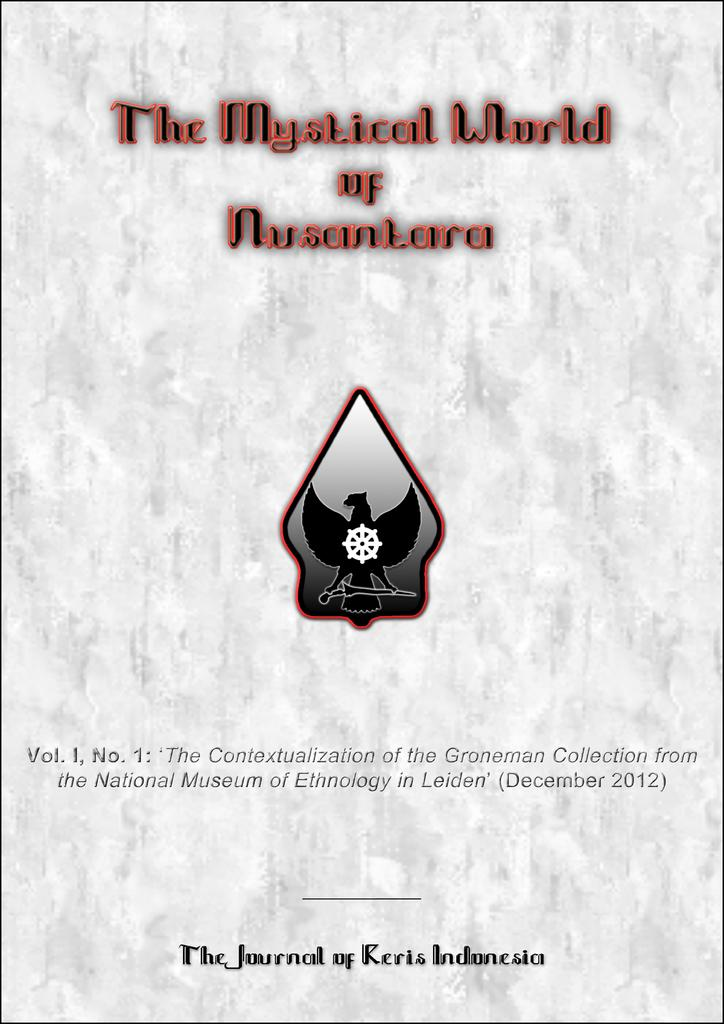<image>
Create a compact narrative representing the image presented. The introduction page of The Mystical World of Nusantara, The Journal of Keris Indonesia. 